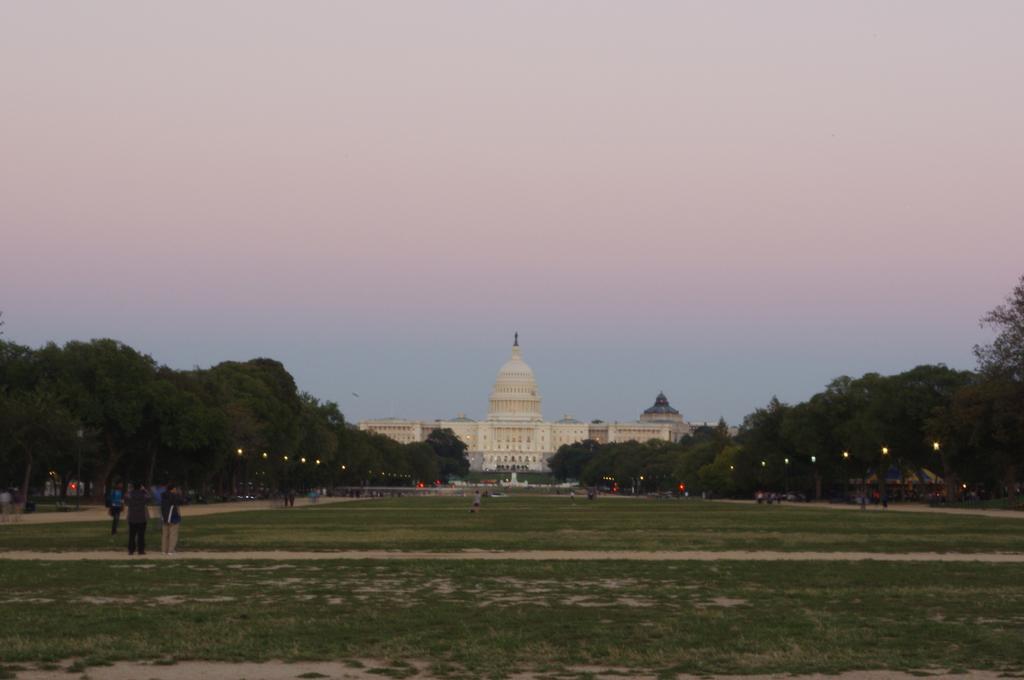In one or two sentences, can you explain what this image depicts? In this picture, we see people walking on the ground. At the bottom of the picture, we see grass. On either side of the picture, there are trees and street lights. In the background, we see a building in white color. At the top of the picture, we see the sky. 